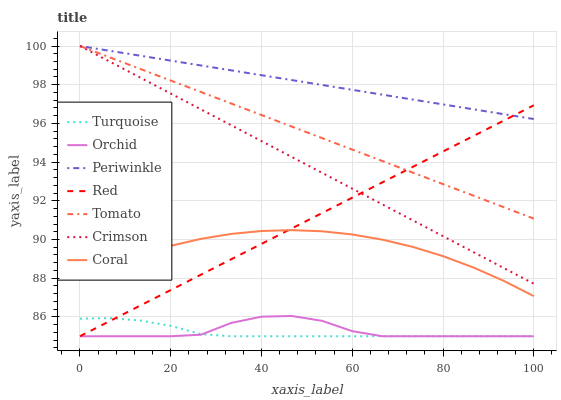Does Turquoise have the minimum area under the curve?
Answer yes or no. Yes. Does Periwinkle have the maximum area under the curve?
Answer yes or no. Yes. Does Coral have the minimum area under the curve?
Answer yes or no. No. Does Coral have the maximum area under the curve?
Answer yes or no. No. Is Periwinkle the smoothest?
Answer yes or no. Yes. Is Orchid the roughest?
Answer yes or no. Yes. Is Turquoise the smoothest?
Answer yes or no. No. Is Turquoise the roughest?
Answer yes or no. No. Does Turquoise have the lowest value?
Answer yes or no. Yes. Does Coral have the lowest value?
Answer yes or no. No. Does Crimson have the highest value?
Answer yes or no. Yes. Does Coral have the highest value?
Answer yes or no. No. Is Turquoise less than Tomato?
Answer yes or no. Yes. Is Tomato greater than Orchid?
Answer yes or no. Yes. Does Turquoise intersect Orchid?
Answer yes or no. Yes. Is Turquoise less than Orchid?
Answer yes or no. No. Is Turquoise greater than Orchid?
Answer yes or no. No. Does Turquoise intersect Tomato?
Answer yes or no. No. 